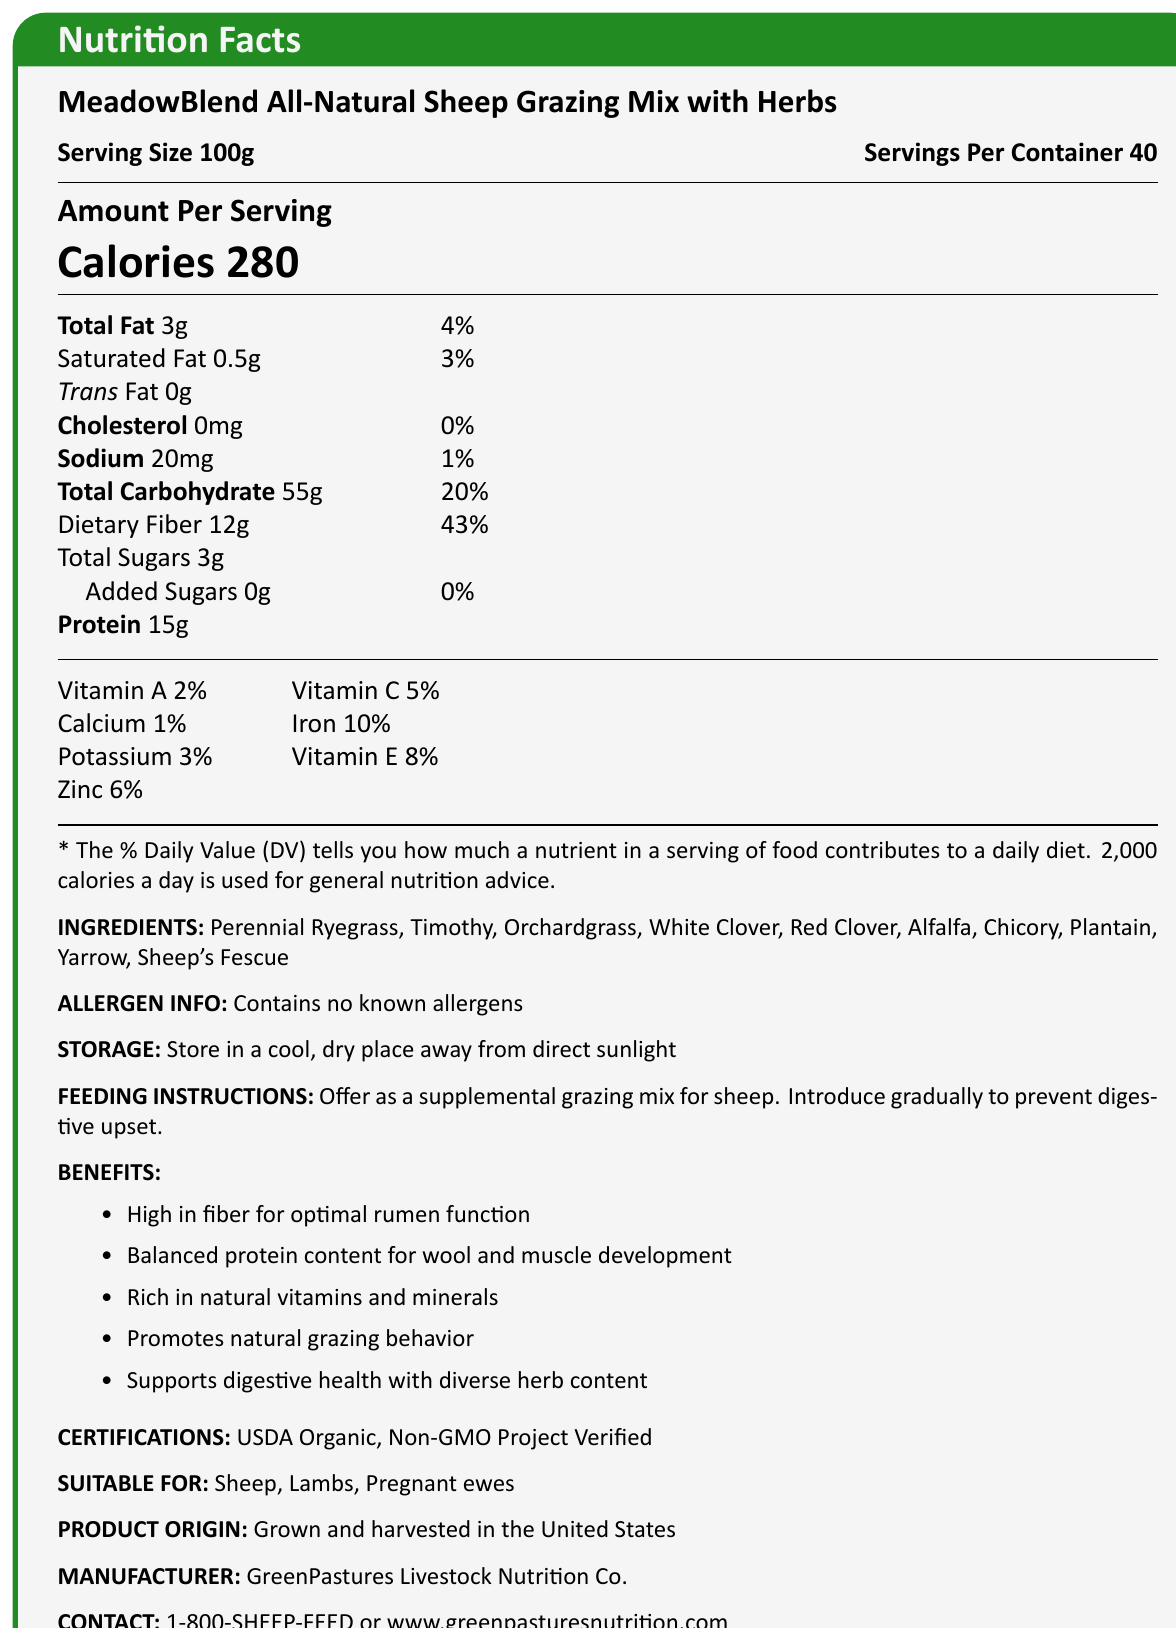what is the serving size? The document specifies "Serving Size 100g" at the top under the product name.
Answer: 100g how many servings are in the container? The document states "Servings Per Container 40" at the top under the product name.
Answer: 40 how many calories are in one serving? The document prominently displays "Calories 280" in the "Amount Per Serving" section.
Answer: 280 what is the total fat content per serving? Under the "Amount Per Serving" section, it states "Total Fat 3g".
Answer: 3g what percentage of the daily value of dietary fiber does a serving provide? The "Amount Per Serving" section lists "Dietary Fiber 12g" with "43%" Daily Value next to it.
Answer: 43% what are the main ingredients in the grazing mix? The "INGREDIENTS" section lists all the main ingredients.
Answer: Perennial Ryegrass, Timothy, Orchardgrass, White Clover, Red Clover, Alfalfa, Chicory, Plantain, Yarrow, Sheep's Fescue is the product USDA organic certified? Under the "CERTIFICATIONS" section, the document lists "USDA Organic".
Answer: Yes what is the protein content in one serving? The "Amount Per Serving" section indicates "Protein 15g".
Answer: 15g which of the following is not listed as an ingredient of the mix? A. Timothy B. Plantain C. Corn D. Alfalfa The "INGREDIENTS" section does not list "Corn" as an ingredient.
Answer: C. Corn how much sodium does one serving contain? The "Amount Per Serving" section lists "Sodium 20mg".
Answer: 20mg how many grams of total sugars are in one serving? Under "Total Carbohydrate", it states "Total Sugars 3g".
Answer: 3g which vitamin has the highest percentage of daily value in a serving? A. Vitamin A B. Vitamin C C. Iron D. Vitamin E The vitamins section lists "Iron 10%" which is the highest compared to the other vitamins mentioned.
Answer: C. Iron is the grazing mix suitable for lambs? The "SUITABLE FOR" section includes "Lambs".
Answer: Yes describe the main benefits of MeadowBlend All-Natural Sheep Grazing Mix. The benefits listed in the document include high fiber, balanced protein, rich vitamins/minerals, natural grazing behavior, and digestive health benefits.
Answer: High in fiber for optimal rumen function, balanced protein content for wool and muscle development, rich in natural vitamins and minerals, promotes natural grazing behavior, supports digestive health with diverse herb content what is the contact number for GreenPastures Livestock Nutrition Co.? The manufacturer’s contact information at the bottom provides this number.
Answer: 1-800-SHEEP-FEED how should the grazing mix be stored? The "STORAGE" section provides these instructions.
Answer: Store in a cool, dry place away from direct sunlight determine the daily value percentage of Vitamin D in the grazing mix. The document does not provide information about the Vitamin D content or its daily value percentage.
Answer: Not enough information 